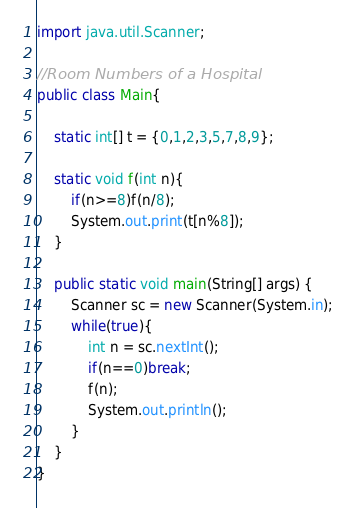Convert code to text. <code><loc_0><loc_0><loc_500><loc_500><_Java_>import java.util.Scanner;

//Room Numbers of a Hospital
public class Main{

	static int[] t = {0,1,2,3,5,7,8,9};
	
	static void f(int n){
		if(n>=8)f(n/8);
		System.out.print(t[n%8]);
	}
	
	public static void main(String[] args) {
		Scanner sc = new Scanner(System.in);
		while(true){
			int n = sc.nextInt();
			if(n==0)break;
			f(n);
			System.out.println();
		}
	}
}</code> 